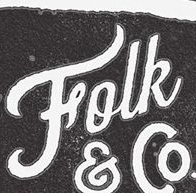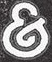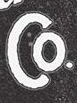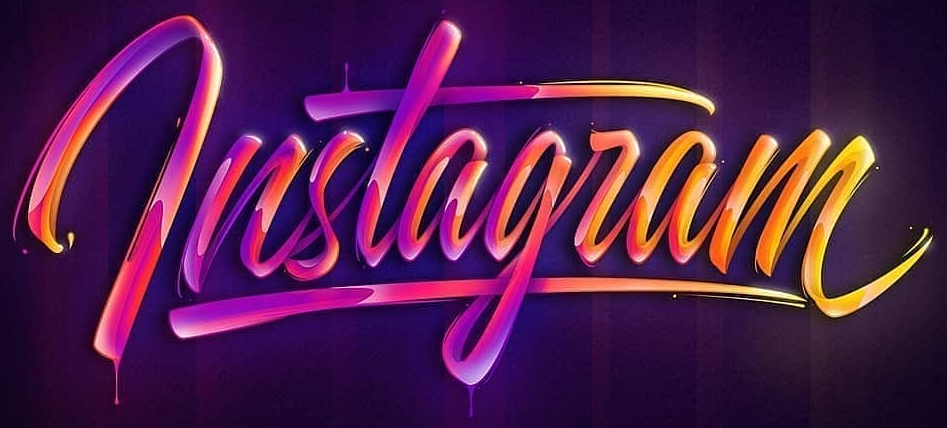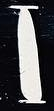Read the text content from these images in order, separated by a semicolon. Folk; &; Co; lnstagram; I 